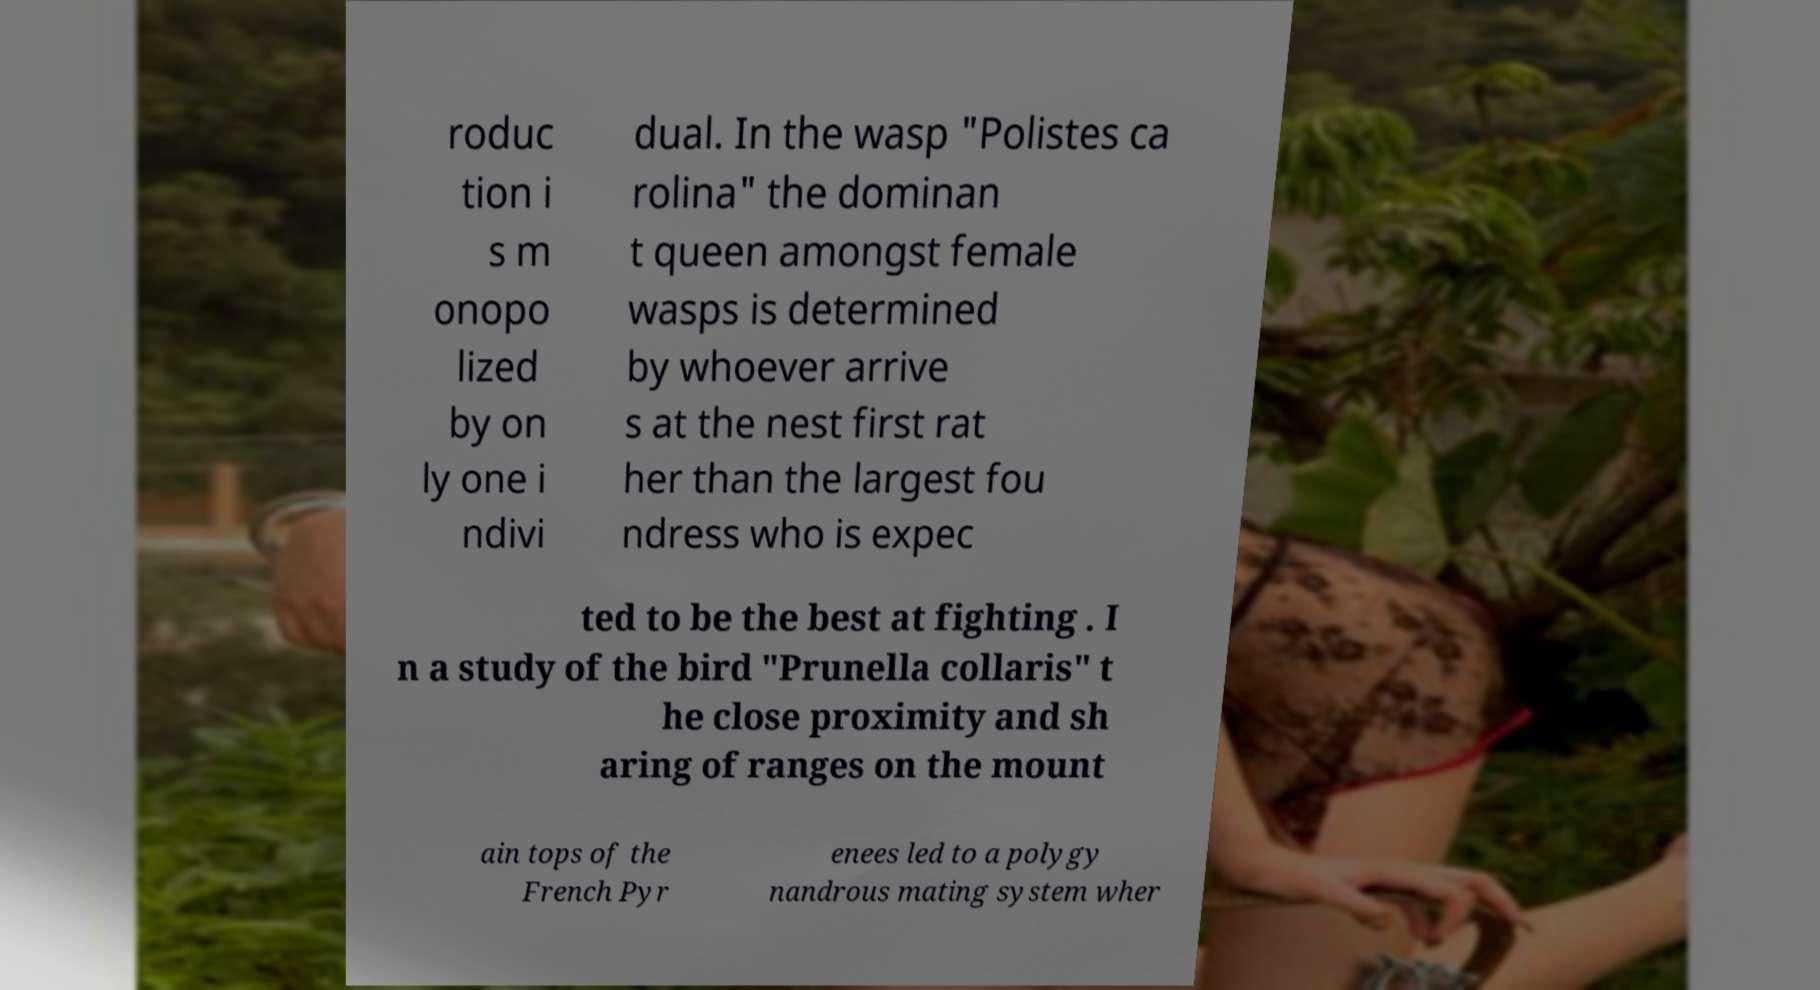Please identify and transcribe the text found in this image. roduc tion i s m onopo lized by on ly one i ndivi dual. In the wasp "Polistes ca rolina" the dominan t queen amongst female wasps is determined by whoever arrive s at the nest first rat her than the largest fou ndress who is expec ted to be the best at fighting . I n a study of the bird "Prunella collaris" t he close proximity and sh aring of ranges on the mount ain tops of the French Pyr enees led to a polygy nandrous mating system wher 